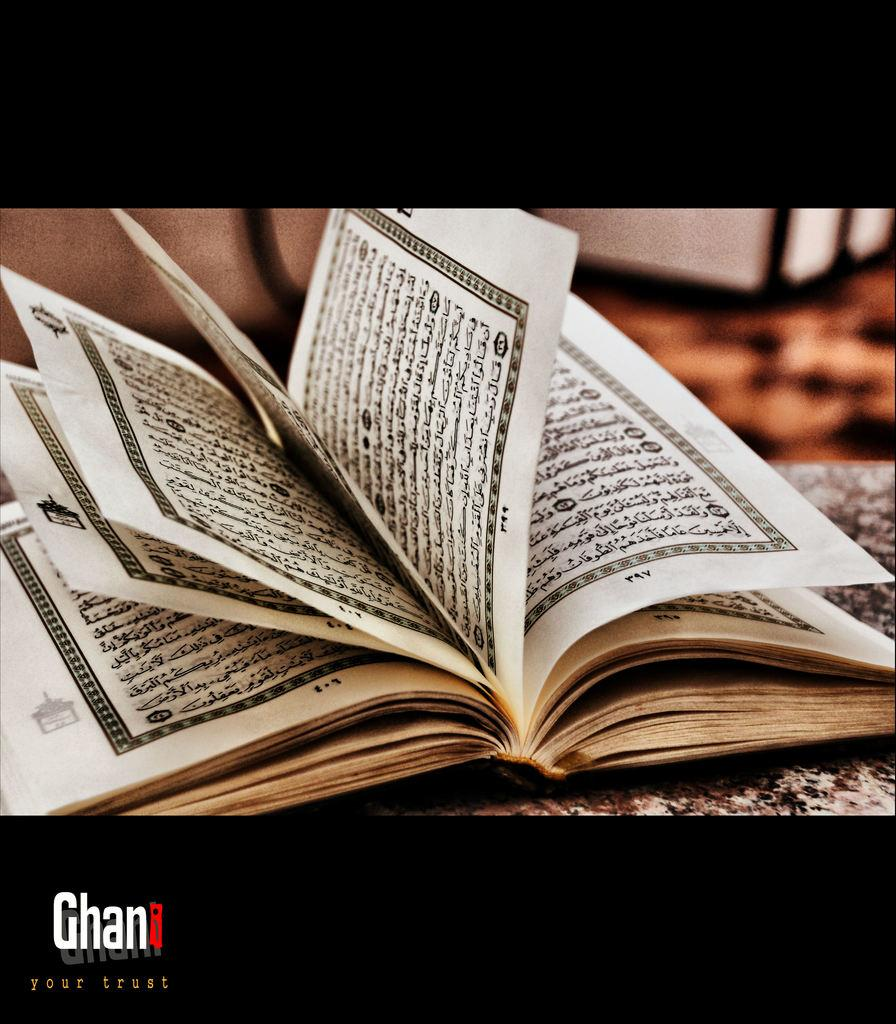<image>
Offer a succinct explanation of the picture presented. the word Ghan is under a book that is opened 